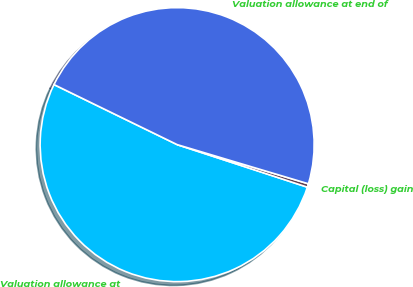<chart> <loc_0><loc_0><loc_500><loc_500><pie_chart><fcel>Valuation allowance at<fcel>Capital (loss) gain<fcel>Valuation allowance at end of<nl><fcel>52.19%<fcel>0.41%<fcel>47.4%<nl></chart> 